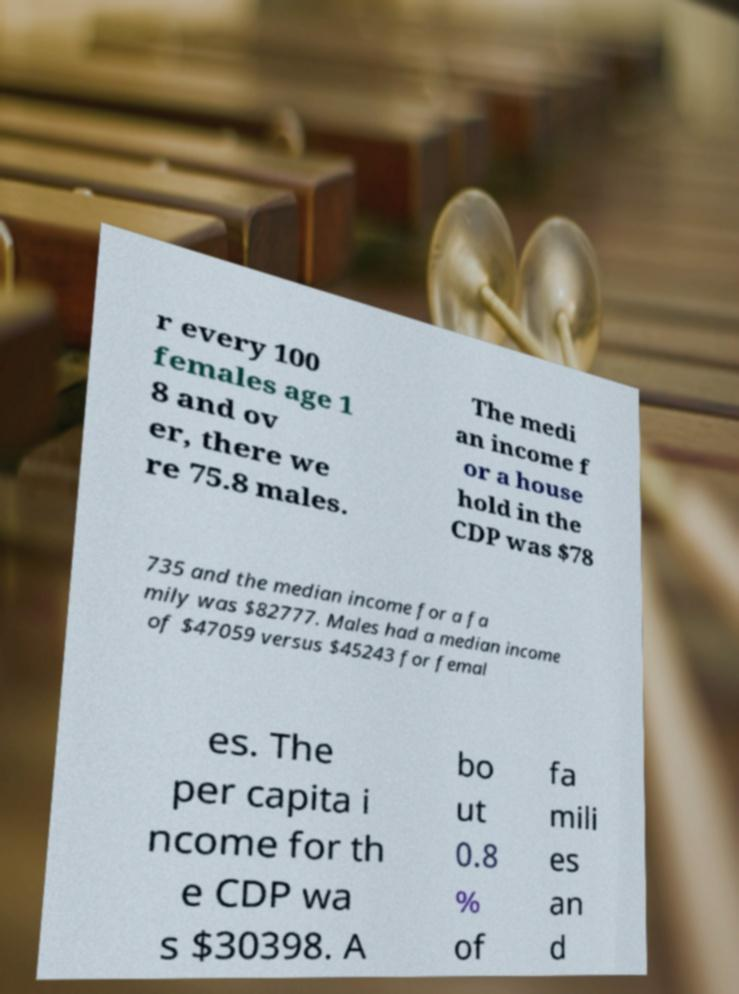Please identify and transcribe the text found in this image. r every 100 females age 1 8 and ov er, there we re 75.8 males. The medi an income f or a house hold in the CDP was $78 735 and the median income for a fa mily was $82777. Males had a median income of $47059 versus $45243 for femal es. The per capita i ncome for th e CDP wa s $30398. A bo ut 0.8 % of fa mili es an d 